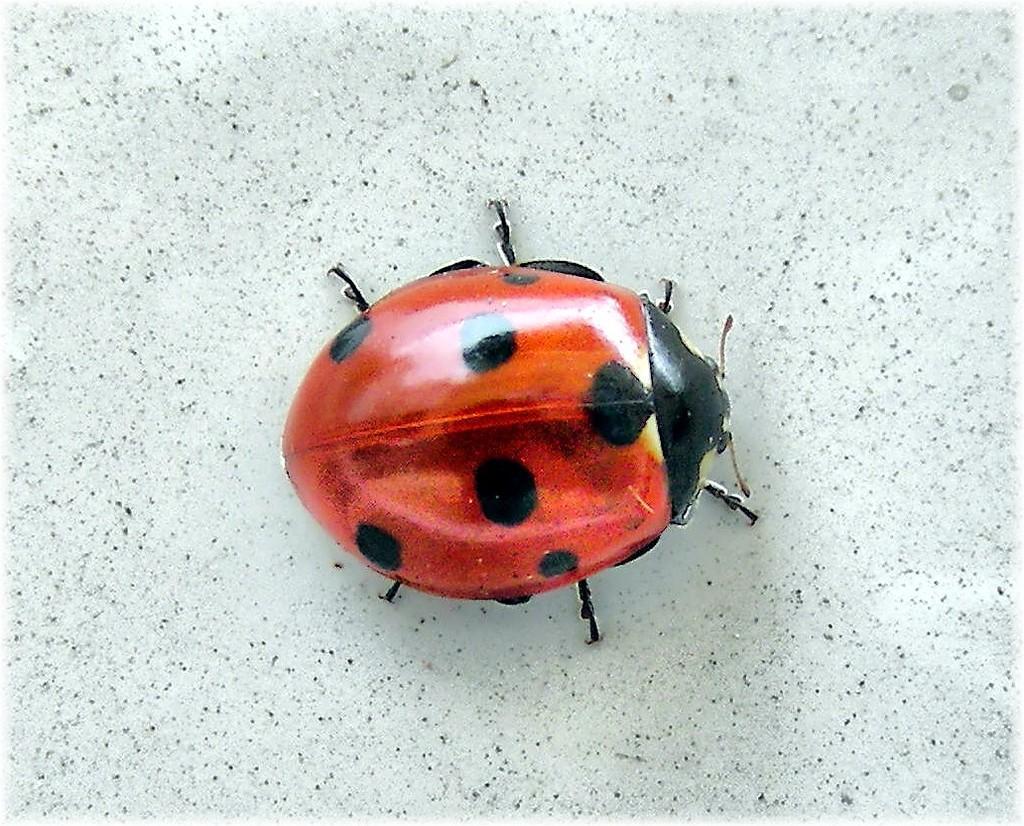Describe this image in one or two sentences. This image consists of an insect in red and black color. In the background, there is a floor. 